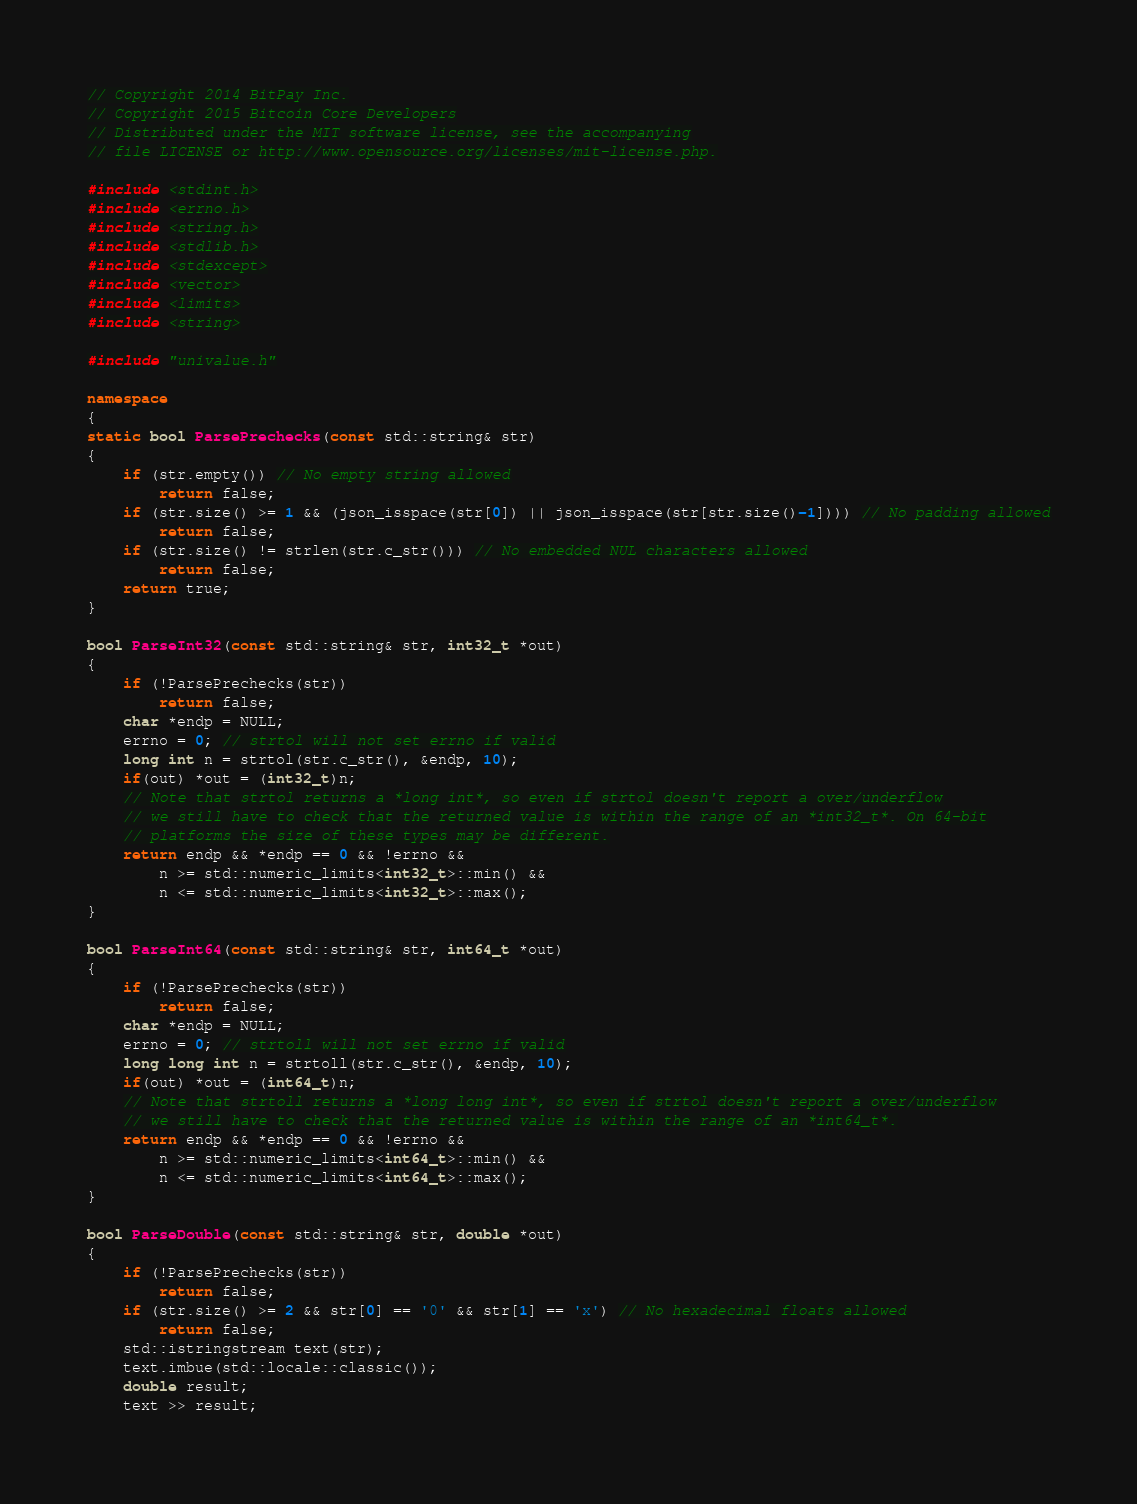<code> <loc_0><loc_0><loc_500><loc_500><_C++_>// Copyright 2014 BitPay Inc.
// Copyright 2015 Bitcoin Core Developers
// Distributed under the MIT software license, see the accompanying
// file LICENSE or http://www.opensource.org/licenses/mit-license.php.

#include <stdint.h>
#include <errno.h>
#include <string.h>
#include <stdlib.h>
#include <stdexcept>
#include <vector>
#include <limits>
#include <string>

#include "univalue.h"

namespace
{
static bool ParsePrechecks(const std::string& str)
{
    if (str.empty()) // No empty string allowed
        return false;
    if (str.size() >= 1 && (json_isspace(str[0]) || json_isspace(str[str.size()-1]))) // No padding allowed
        return false;
    if (str.size() != strlen(str.c_str())) // No embedded NUL characters allowed
        return false;
    return true;
}

bool ParseInt32(const std::string& str, int32_t *out)
{
    if (!ParsePrechecks(str))
        return false;
    char *endp = NULL;
    errno = 0; // strtol will not set errno if valid
    long int n = strtol(str.c_str(), &endp, 10);
    if(out) *out = (int32_t)n;
    // Note that strtol returns a *long int*, so even if strtol doesn't report a over/underflow
    // we still have to check that the returned value is within the range of an *int32_t*. On 64-bit
    // platforms the size of these types may be different.
    return endp && *endp == 0 && !errno &&
        n >= std::numeric_limits<int32_t>::min() &&
        n <= std::numeric_limits<int32_t>::max();
}

bool ParseInt64(const std::string& str, int64_t *out)
{
    if (!ParsePrechecks(str))
        return false;
    char *endp = NULL;
    errno = 0; // strtoll will not set errno if valid
    long long int n = strtoll(str.c_str(), &endp, 10);
    if(out) *out = (int64_t)n;
    // Note that strtoll returns a *long long int*, so even if strtol doesn't report a over/underflow
    // we still have to check that the returned value is within the range of an *int64_t*.
    return endp && *endp == 0 && !errno &&
        n >= std::numeric_limits<int64_t>::min() &&
        n <= std::numeric_limits<int64_t>::max();
}

bool ParseDouble(const std::string& str, double *out)
{
    if (!ParsePrechecks(str))
        return false;
    if (str.size() >= 2 && str[0] == '0' && str[1] == 'x') // No hexadecimal floats allowed
        return false;
    std::istringstream text(str);
    text.imbue(std::locale::classic());
    double result;
    text >> result;</code> 